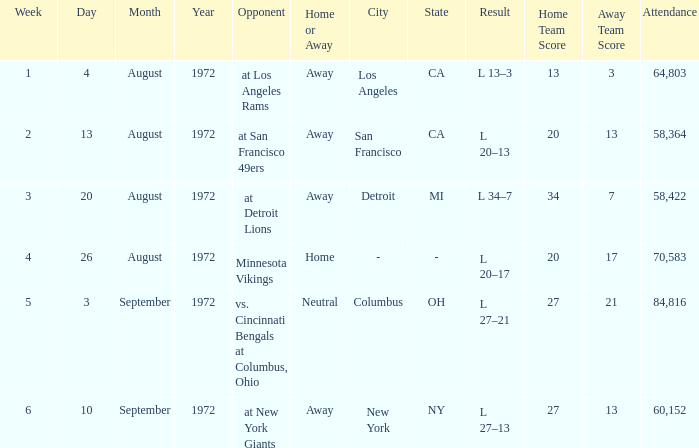What is the lowest attendance on September 3, 1972? 84816.0. 